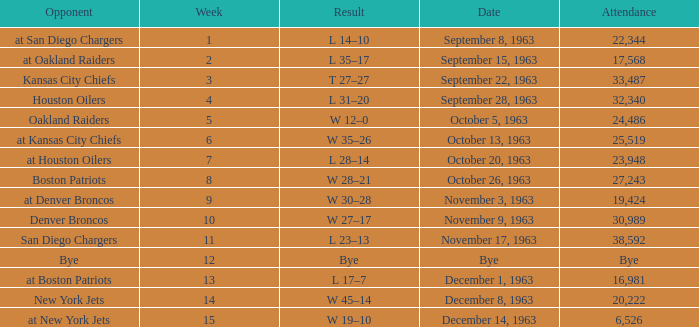Which Result has a Week smaller than 11, and Attendance of 17,568? L 35–17. 